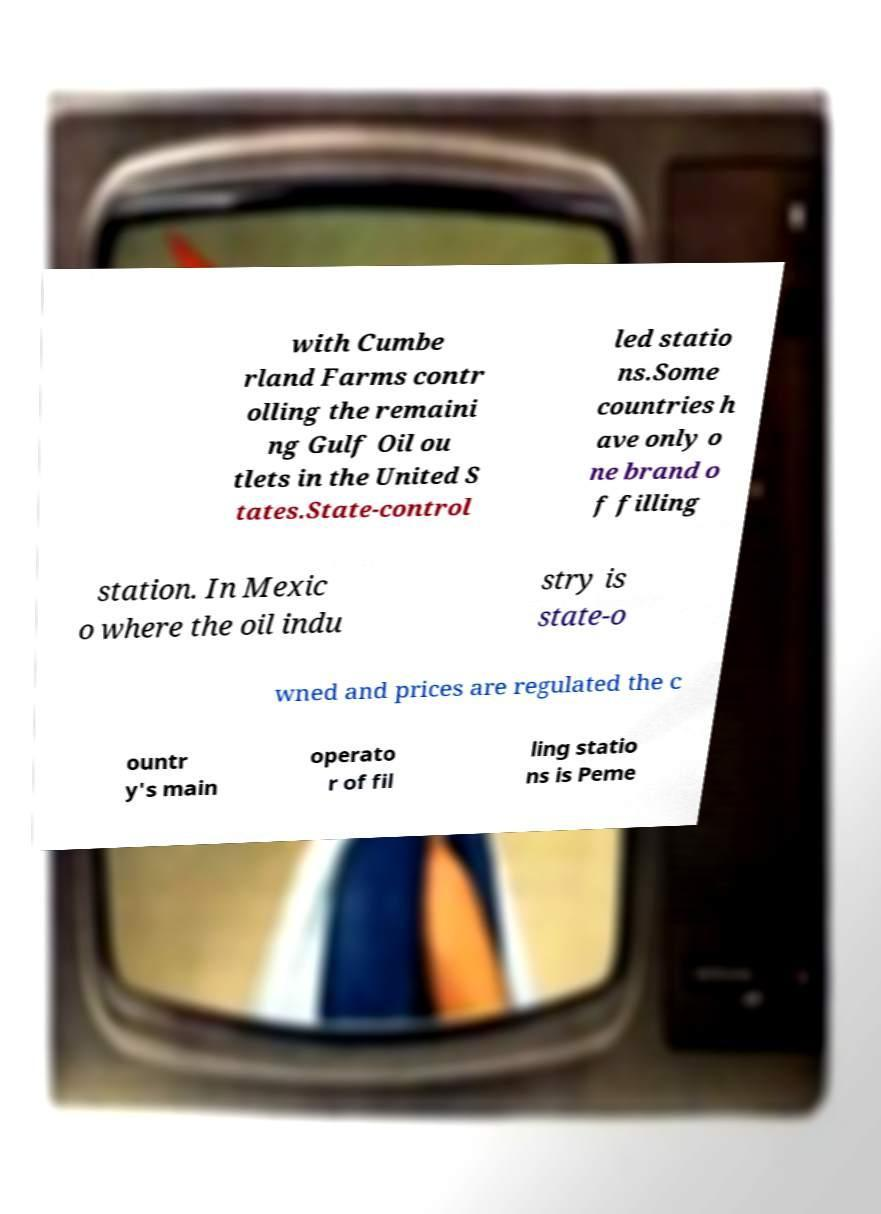For documentation purposes, I need the text within this image transcribed. Could you provide that? with Cumbe rland Farms contr olling the remaini ng Gulf Oil ou tlets in the United S tates.State-control led statio ns.Some countries h ave only o ne brand o f filling station. In Mexic o where the oil indu stry is state-o wned and prices are regulated the c ountr y's main operato r of fil ling statio ns is Peme 